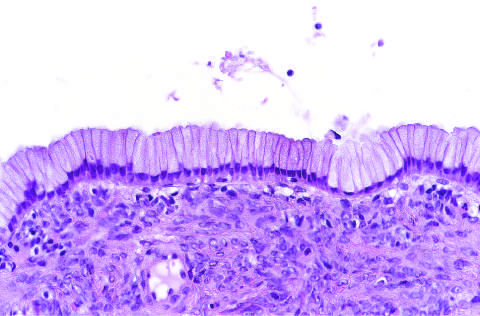re a few residual cardiac muscle cells lined by columnar mucinous epithelium, with a densely cellular ovarian stroma?
Answer the question using a single word or phrase. No 